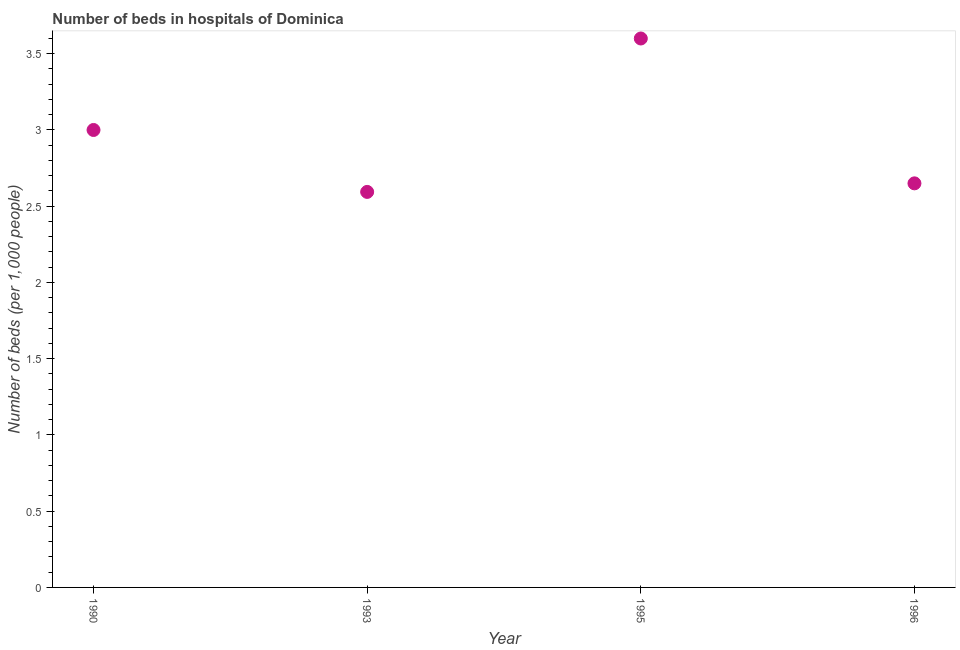What is the number of hospital beds in 1993?
Your answer should be very brief. 2.59. Across all years, what is the minimum number of hospital beds?
Your answer should be compact. 2.59. What is the sum of the number of hospital beds?
Provide a succinct answer. 11.84. What is the difference between the number of hospital beds in 1990 and 1996?
Give a very brief answer. 0.35. What is the average number of hospital beds per year?
Keep it short and to the point. 2.96. What is the median number of hospital beds?
Keep it short and to the point. 2.83. What is the ratio of the number of hospital beds in 1993 to that in 1995?
Ensure brevity in your answer.  0.72. Is the number of hospital beds in 1990 less than that in 1993?
Your response must be concise. No. What is the difference between the highest and the second highest number of hospital beds?
Ensure brevity in your answer.  0.6. Is the sum of the number of hospital beds in 1990 and 1993 greater than the maximum number of hospital beds across all years?
Offer a very short reply. Yes. What is the difference between the highest and the lowest number of hospital beds?
Offer a very short reply. 1.01. In how many years, is the number of hospital beds greater than the average number of hospital beds taken over all years?
Your answer should be compact. 2. How many dotlines are there?
Your response must be concise. 1. What is the difference between two consecutive major ticks on the Y-axis?
Keep it short and to the point. 0.5. Are the values on the major ticks of Y-axis written in scientific E-notation?
Ensure brevity in your answer.  No. Does the graph contain any zero values?
Offer a very short reply. No. What is the title of the graph?
Provide a short and direct response. Number of beds in hospitals of Dominica. What is the label or title of the Y-axis?
Your answer should be very brief. Number of beds (per 1,0 people). What is the Number of beds (per 1,000 people) in 1990?
Ensure brevity in your answer.  3. What is the Number of beds (per 1,000 people) in 1993?
Offer a terse response. 2.59. What is the Number of beds (per 1,000 people) in 1995?
Provide a succinct answer. 3.6. What is the Number of beds (per 1,000 people) in 1996?
Offer a terse response. 2.65. What is the difference between the Number of beds (per 1,000 people) in 1990 and 1993?
Offer a terse response. 0.41. What is the difference between the Number of beds (per 1,000 people) in 1990 and 1996?
Offer a terse response. 0.35. What is the difference between the Number of beds (per 1,000 people) in 1993 and 1995?
Give a very brief answer. -1.01. What is the difference between the Number of beds (per 1,000 people) in 1993 and 1996?
Ensure brevity in your answer.  -0.06. What is the ratio of the Number of beds (per 1,000 people) in 1990 to that in 1993?
Your answer should be compact. 1.16. What is the ratio of the Number of beds (per 1,000 people) in 1990 to that in 1995?
Provide a short and direct response. 0.83. What is the ratio of the Number of beds (per 1,000 people) in 1990 to that in 1996?
Offer a very short reply. 1.13. What is the ratio of the Number of beds (per 1,000 people) in 1993 to that in 1995?
Your response must be concise. 0.72. What is the ratio of the Number of beds (per 1,000 people) in 1993 to that in 1996?
Your answer should be very brief. 0.98. What is the ratio of the Number of beds (per 1,000 people) in 1995 to that in 1996?
Your answer should be very brief. 1.36. 